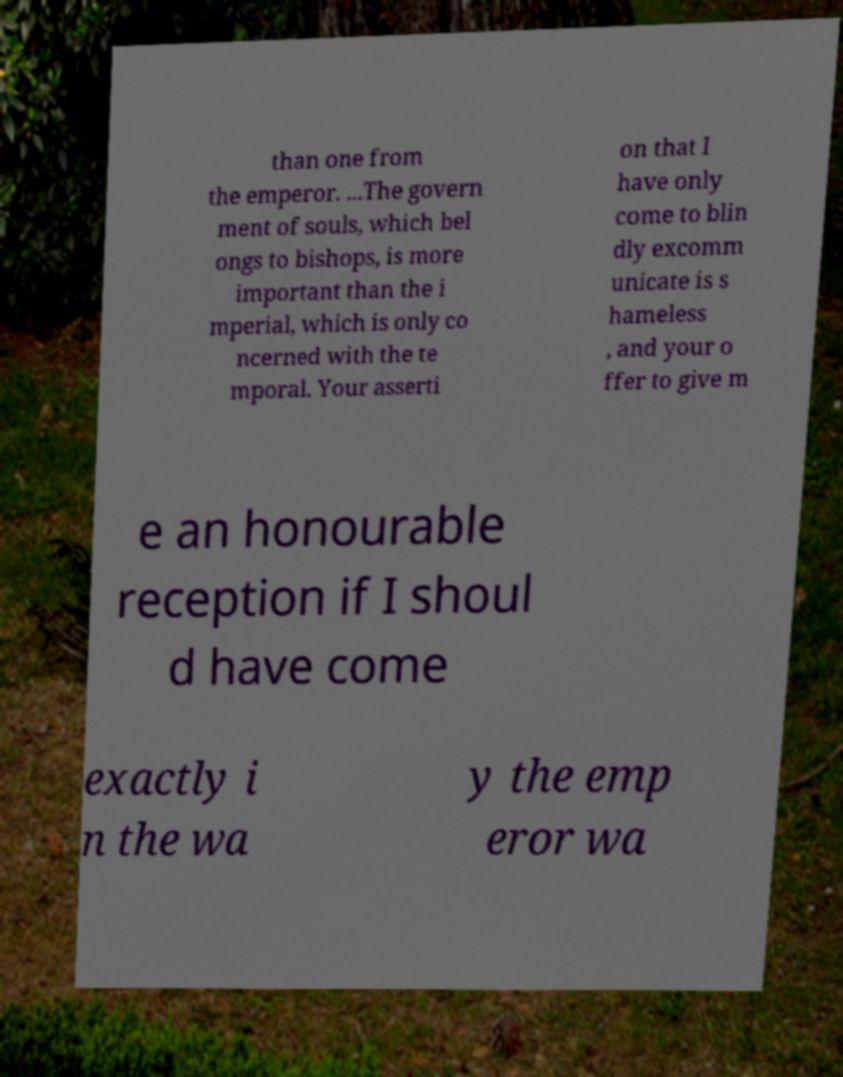There's text embedded in this image that I need extracted. Can you transcribe it verbatim? than one from the emperor. ...The govern ment of souls, which bel ongs to bishops, is more important than the i mperial, which is only co ncerned with the te mporal. Your asserti on that I have only come to blin dly excomm unicate is s hameless , and your o ffer to give m e an honourable reception if I shoul d have come exactly i n the wa y the emp eror wa 